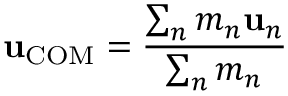<formula> <loc_0><loc_0><loc_500><loc_500>u _ { C O M } = { \frac { \sum _ { n } m _ { n } u _ { n } } { \sum _ { n } m _ { n } } }</formula> 